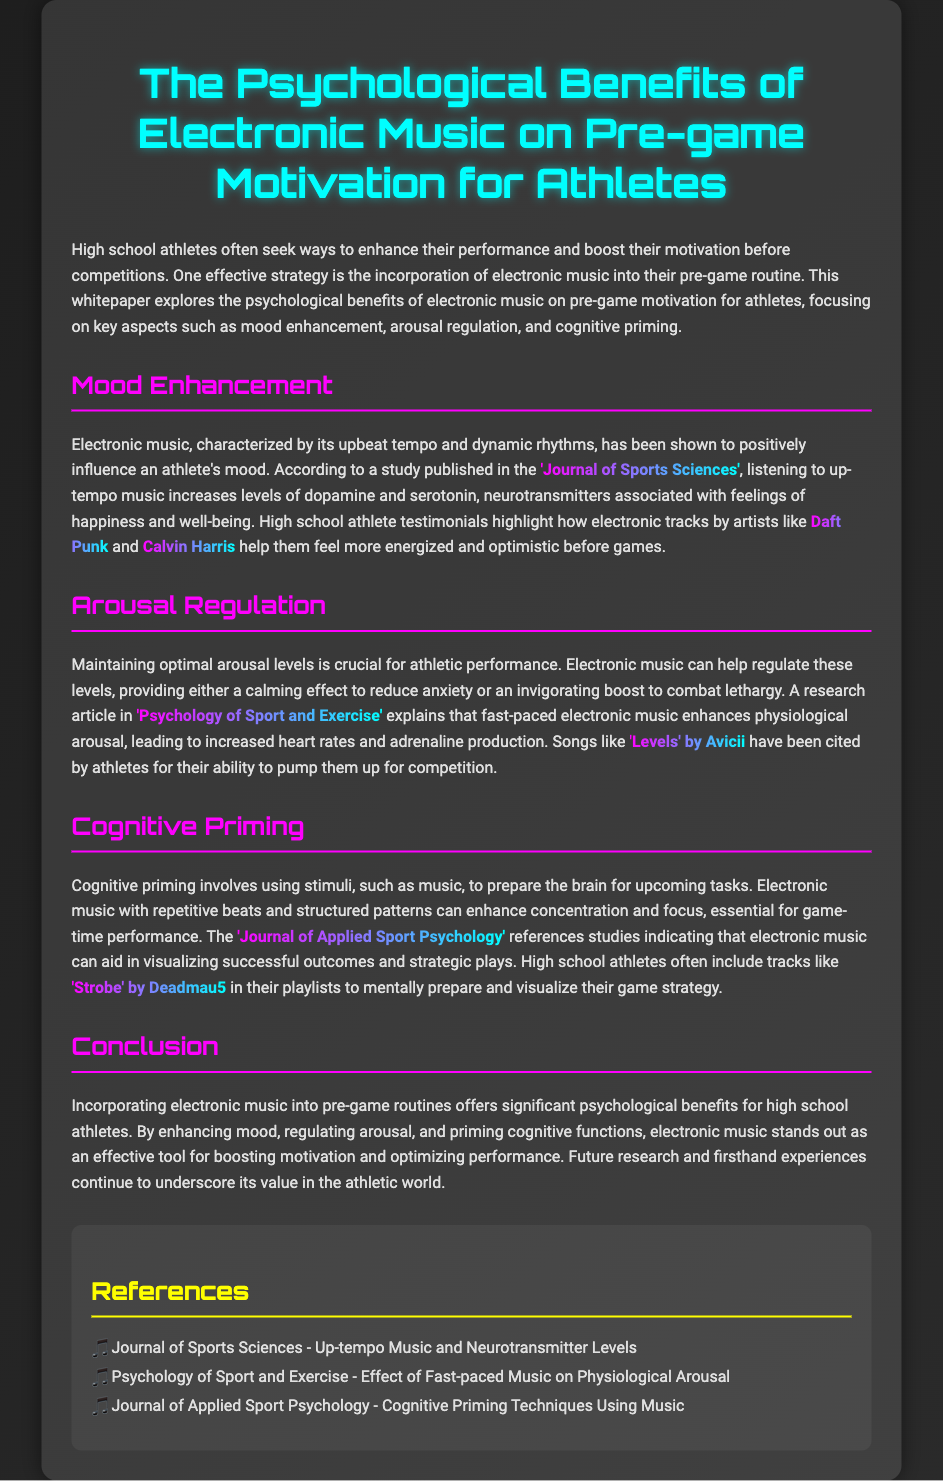What is the title of the whitepaper? The title is prominently displayed at the top of the document and provides the main focus of the study.
Answer: The Psychological Benefits of Electronic Music on Pre-game Motivation for Athletes Which neurotransmitters are associated with mood enhancement according to the document? The document mentions specific neurotransmitters that electronic music increases, relevant to the mood of athletes.
Answer: Dopamine and serotonin Who are two artists mentioned that produce electronic music? The document includes notable electronic music artists that athletes listen to for motivation.
Answer: Daft Punk and Calvin Harris What is one effect of fast-paced electronic music? The document explains a specific physiological effect that fast-paced electronic music has on athletes before games.
Answer: Increases heart rates What is cognitive priming? The document defines a concept related to preparing the brain for tasks, which is influenced by music.
Answer: Using stimuli to prepare the brain Which track by Avicii is cited as an energizing song? The document provides an example of a song known for pumping up athletes before competition.
Answer: Levels What are the three key aspects discussed in the whitepaper? The document outlines three main psychological benefits of electronic music for athletes.
Answer: Mood enhancement, arousal regulation, and cognitive priming From which journal is the study on mood enhancement cited? The document provides the source of the research that discusses the relationship between music and mood.
Answer: Journal of Sports Sciences 